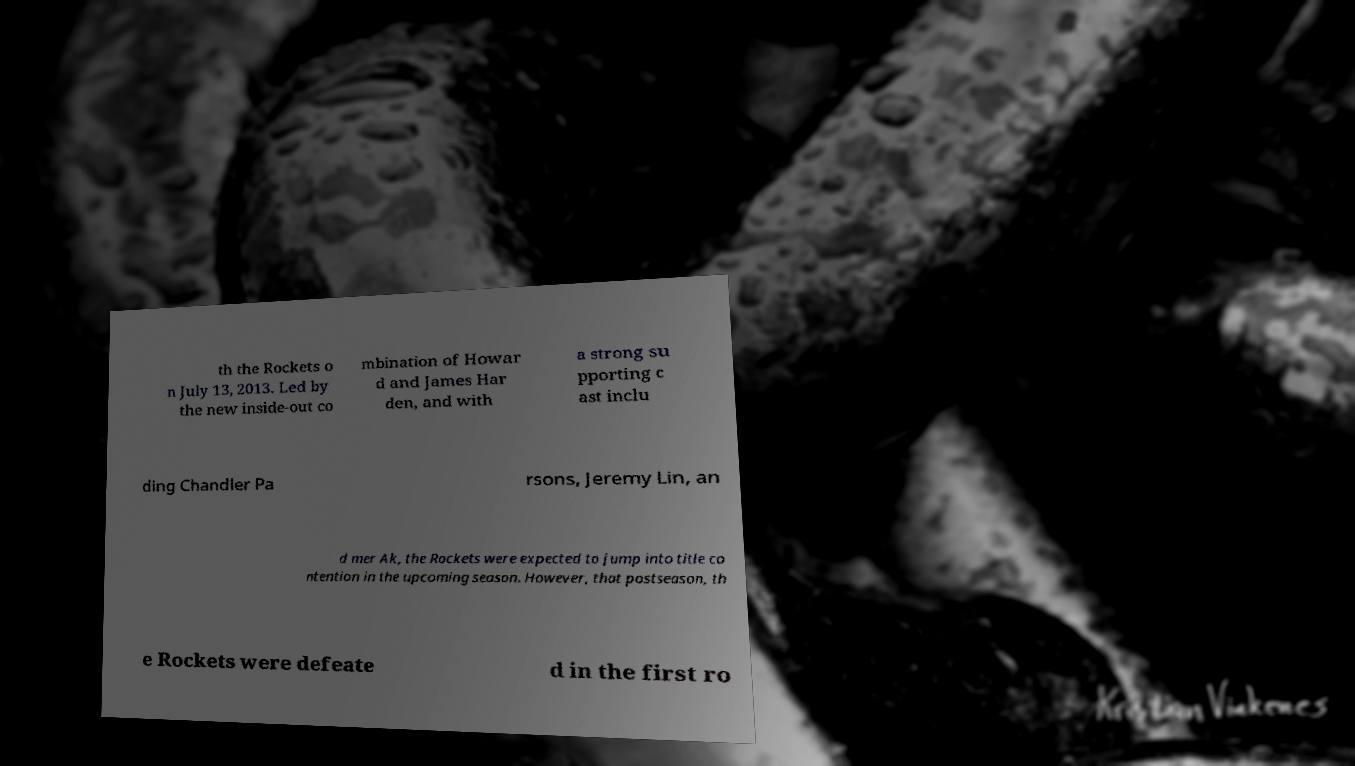Can you accurately transcribe the text from the provided image for me? th the Rockets o n July 13, 2013. Led by the new inside-out co mbination of Howar d and James Har den, and with a strong su pporting c ast inclu ding Chandler Pa rsons, Jeremy Lin, an d mer Ak, the Rockets were expected to jump into title co ntention in the upcoming season. However, that postseason, th e Rockets were defeate d in the first ro 